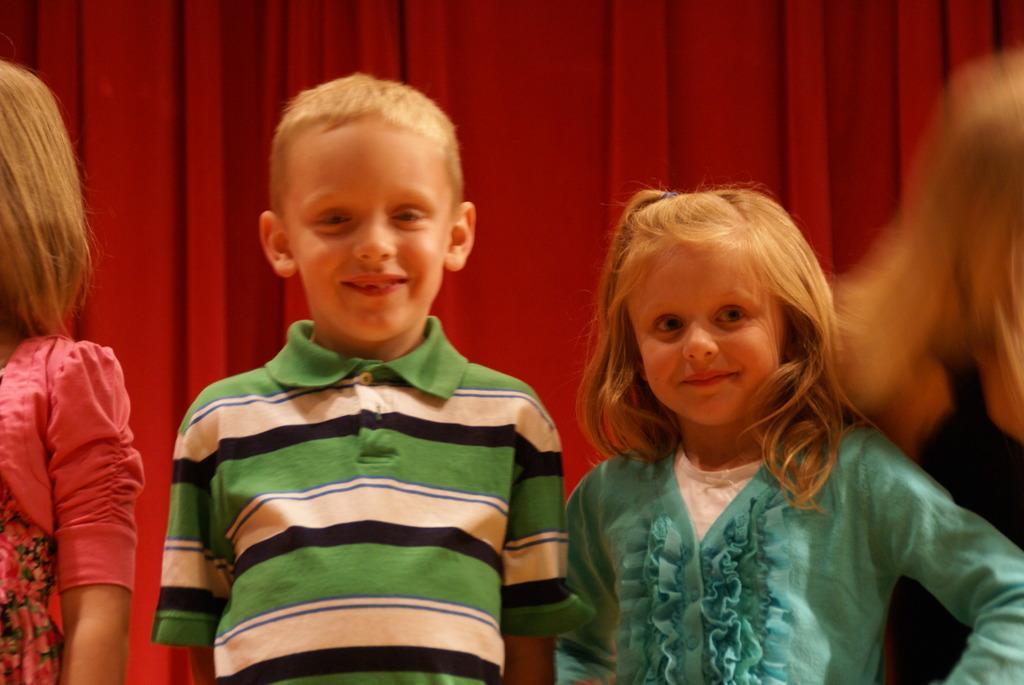Please provide a concise description of this image. In this image in the center there are some children standing, and in the background it looks like a curtain. 